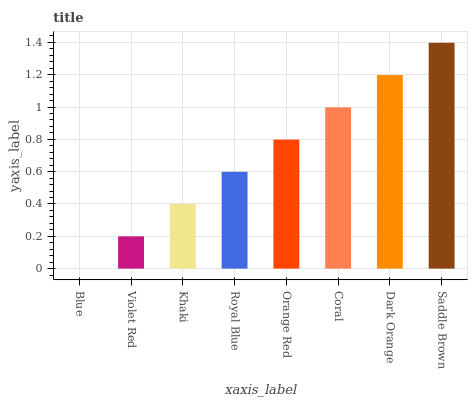Is Violet Red the minimum?
Answer yes or no. No. Is Violet Red the maximum?
Answer yes or no. No. Is Violet Red greater than Blue?
Answer yes or no. Yes. Is Blue less than Violet Red?
Answer yes or no. Yes. Is Blue greater than Violet Red?
Answer yes or no. No. Is Violet Red less than Blue?
Answer yes or no. No. Is Orange Red the high median?
Answer yes or no. Yes. Is Royal Blue the low median?
Answer yes or no. Yes. Is Saddle Brown the high median?
Answer yes or no. No. Is Violet Red the low median?
Answer yes or no. No. 